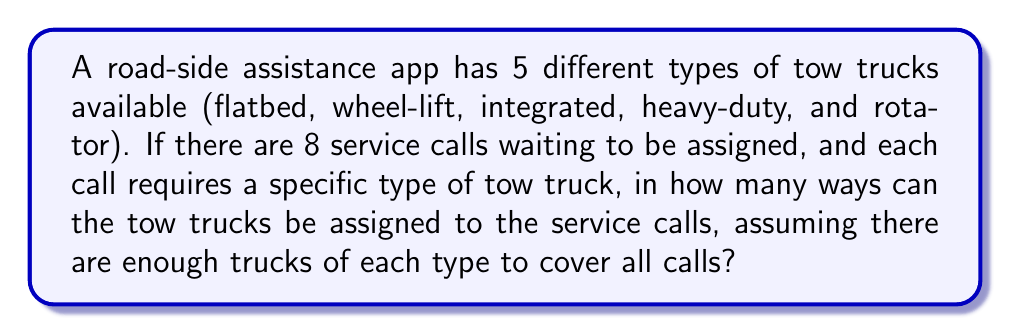Could you help me with this problem? Let's approach this step-by-step:

1) We have 5 types of tow trucks and 8 service calls.

2) For each service call, we need to choose one of the 5 types of tow trucks.

3) This is a case of making independent choices for each service call, where the order matters (as each call is distinct).

4) In combinatorics, when we make a series of independent choices, we multiply the number of options for each choice.

5) For each of the 8 service calls, we have 5 choices of tow truck types.

6) Therefore, we can use the multiplication principle:

   $$\text{Total number of ways} = 5 \times 5 \times 5 \times 5 \times 5 \times 5 \times 5 \times 5$$

7) This can be written as an exponent:

   $$\text{Total number of ways} = 5^8$$

8) Calculating this:

   $$5^8 = 390,625$$

Thus, there are 390,625 ways to assign the tow trucks to the service calls.
Answer: $5^8 = 390,625$ 